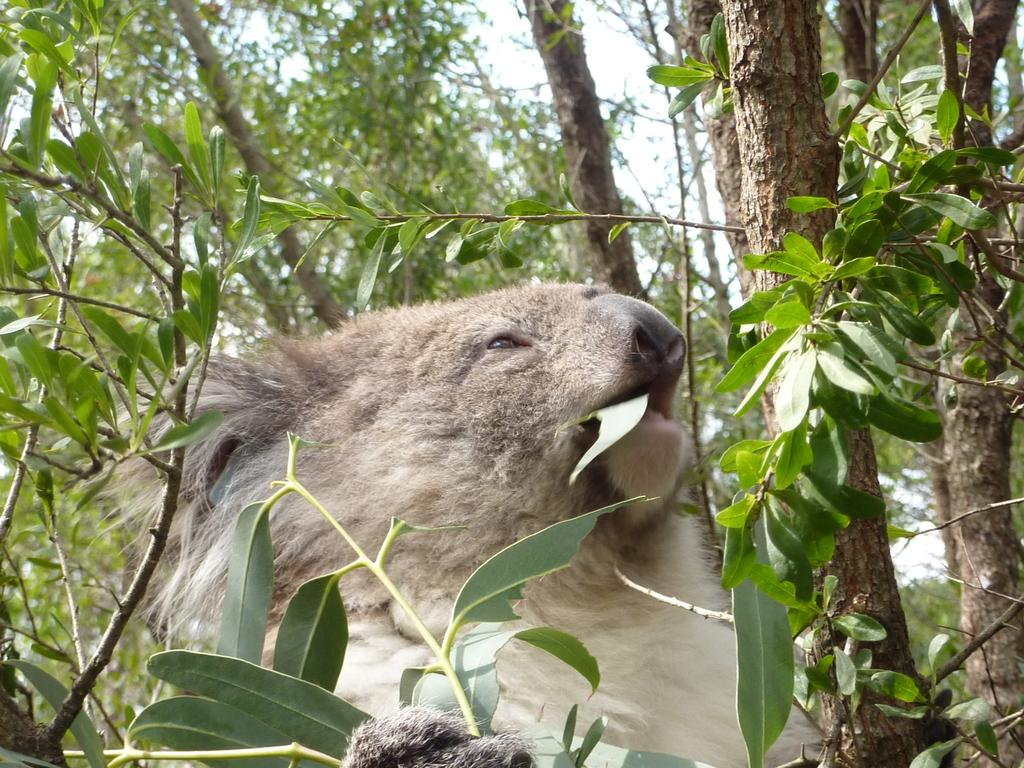What type of living organism is present in the image? There is an animal in the image. What else can be seen in the image besides the animal? There are stems with branches and leaves in the image. What is visible in the background of the image? There are trees in the background of the image. What type of pies can be seen on the sidewalk in the image? There is no mention of pies or a sidewalk in the image; it features an animal, stems with branches and leaves, and trees in the background. 